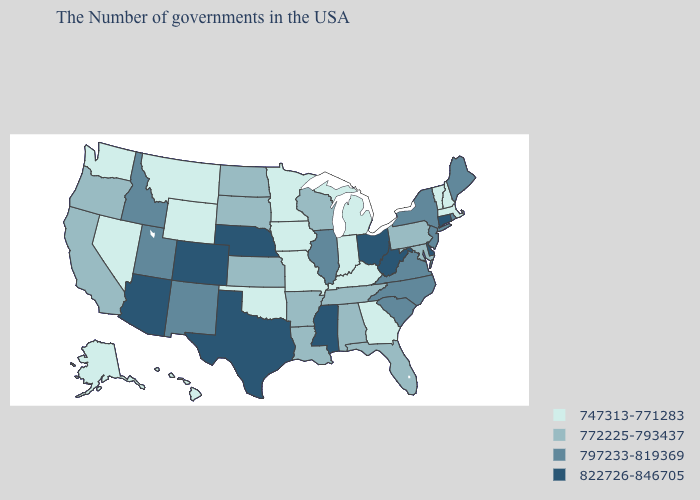Does Maryland have the highest value in the South?
Give a very brief answer. No. Which states have the lowest value in the West?
Be succinct. Wyoming, Montana, Nevada, Washington, Alaska, Hawaii. Does Iowa have a lower value than Indiana?
Short answer required. No. What is the value of Rhode Island?
Write a very short answer. 797233-819369. What is the value of Montana?
Give a very brief answer. 747313-771283. Name the states that have a value in the range 797233-819369?
Concise answer only. Maine, Rhode Island, New York, New Jersey, Virginia, North Carolina, South Carolina, Illinois, New Mexico, Utah, Idaho. Among the states that border Vermont , which have the highest value?
Concise answer only. New York. Name the states that have a value in the range 822726-846705?
Give a very brief answer. Connecticut, Delaware, West Virginia, Ohio, Mississippi, Nebraska, Texas, Colorado, Arizona. Name the states that have a value in the range 797233-819369?
Short answer required. Maine, Rhode Island, New York, New Jersey, Virginia, North Carolina, South Carolina, Illinois, New Mexico, Utah, Idaho. Which states have the lowest value in the South?
Keep it brief. Georgia, Kentucky, Oklahoma. What is the value of Minnesota?
Give a very brief answer. 747313-771283. What is the highest value in the West ?
Answer briefly. 822726-846705. Does the first symbol in the legend represent the smallest category?
Keep it brief. Yes. What is the highest value in states that border Minnesota?
Give a very brief answer. 772225-793437. Name the states that have a value in the range 747313-771283?
Answer briefly. Massachusetts, New Hampshire, Vermont, Georgia, Michigan, Kentucky, Indiana, Missouri, Minnesota, Iowa, Oklahoma, Wyoming, Montana, Nevada, Washington, Alaska, Hawaii. 